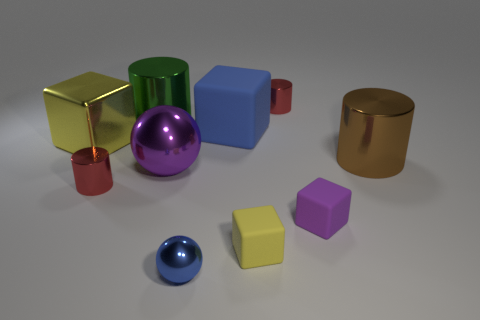There is another thing that is the same color as the large matte object; what is it made of?
Your answer should be very brief. Metal. How many yellow objects are small shiny spheres or large metallic blocks?
Provide a short and direct response. 1. There is a big ball that is the same material as the brown thing; what is its color?
Your answer should be compact. Purple. What number of small objects are metallic balls or gray metal spheres?
Keep it short and to the point. 1. Are there fewer big yellow metal cubes than tiny things?
Provide a short and direct response. Yes. What is the color of the other large object that is the same shape as the large green shiny object?
Offer a terse response. Brown. Is the number of brown matte cylinders greater than the number of large yellow things?
Keep it short and to the point. No. What number of other things are there of the same material as the tiny yellow object
Provide a short and direct response. 2. There is a matte object on the right side of the small cylinder that is behind the purple object that is behind the purple matte block; what shape is it?
Offer a terse response. Cube. Are there fewer large purple metal objects that are on the left side of the yellow metal object than green shiny objects that are to the right of the purple block?
Your response must be concise. No. 